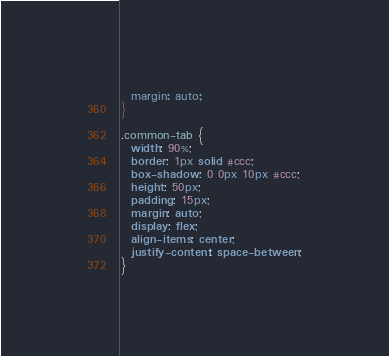<code> <loc_0><loc_0><loc_500><loc_500><_CSS_>  margin: auto;
}

.common-tab {
  width: 90%;
  border: 1px solid #ccc;
  box-shadow: 0 0px 10px #ccc;
  height: 50px;
  padding: 15px;
  margin: auto;
  display: flex;
  align-items: center;
  justify-content: space-between;
}
</code> 